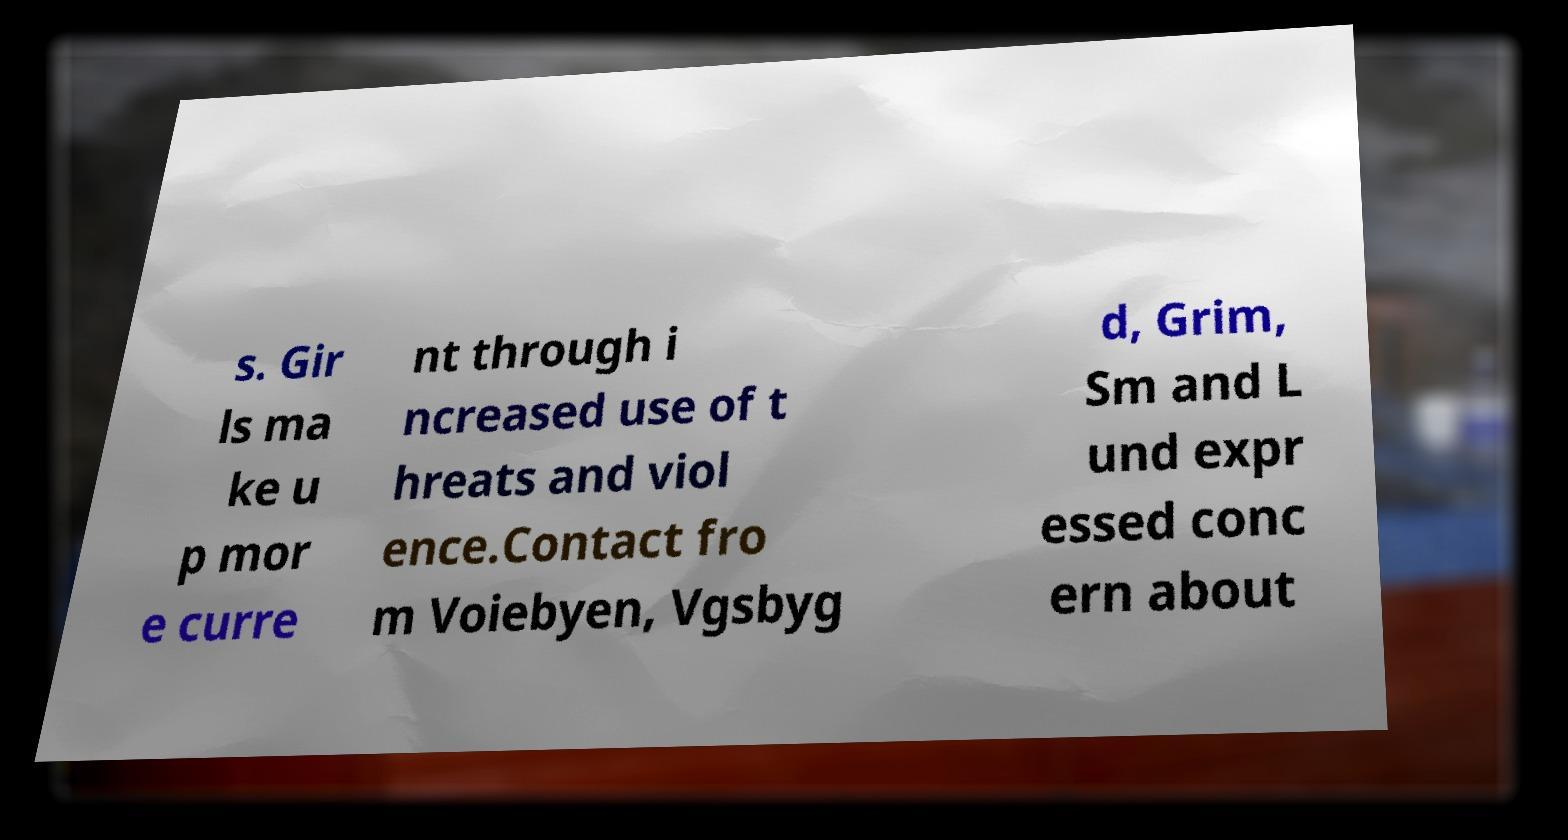What messages or text are displayed in this image? I need them in a readable, typed format. s. Gir ls ma ke u p mor e curre nt through i ncreased use of t hreats and viol ence.Contact fro m Voiebyen, Vgsbyg d, Grim, Sm and L und expr essed conc ern about 